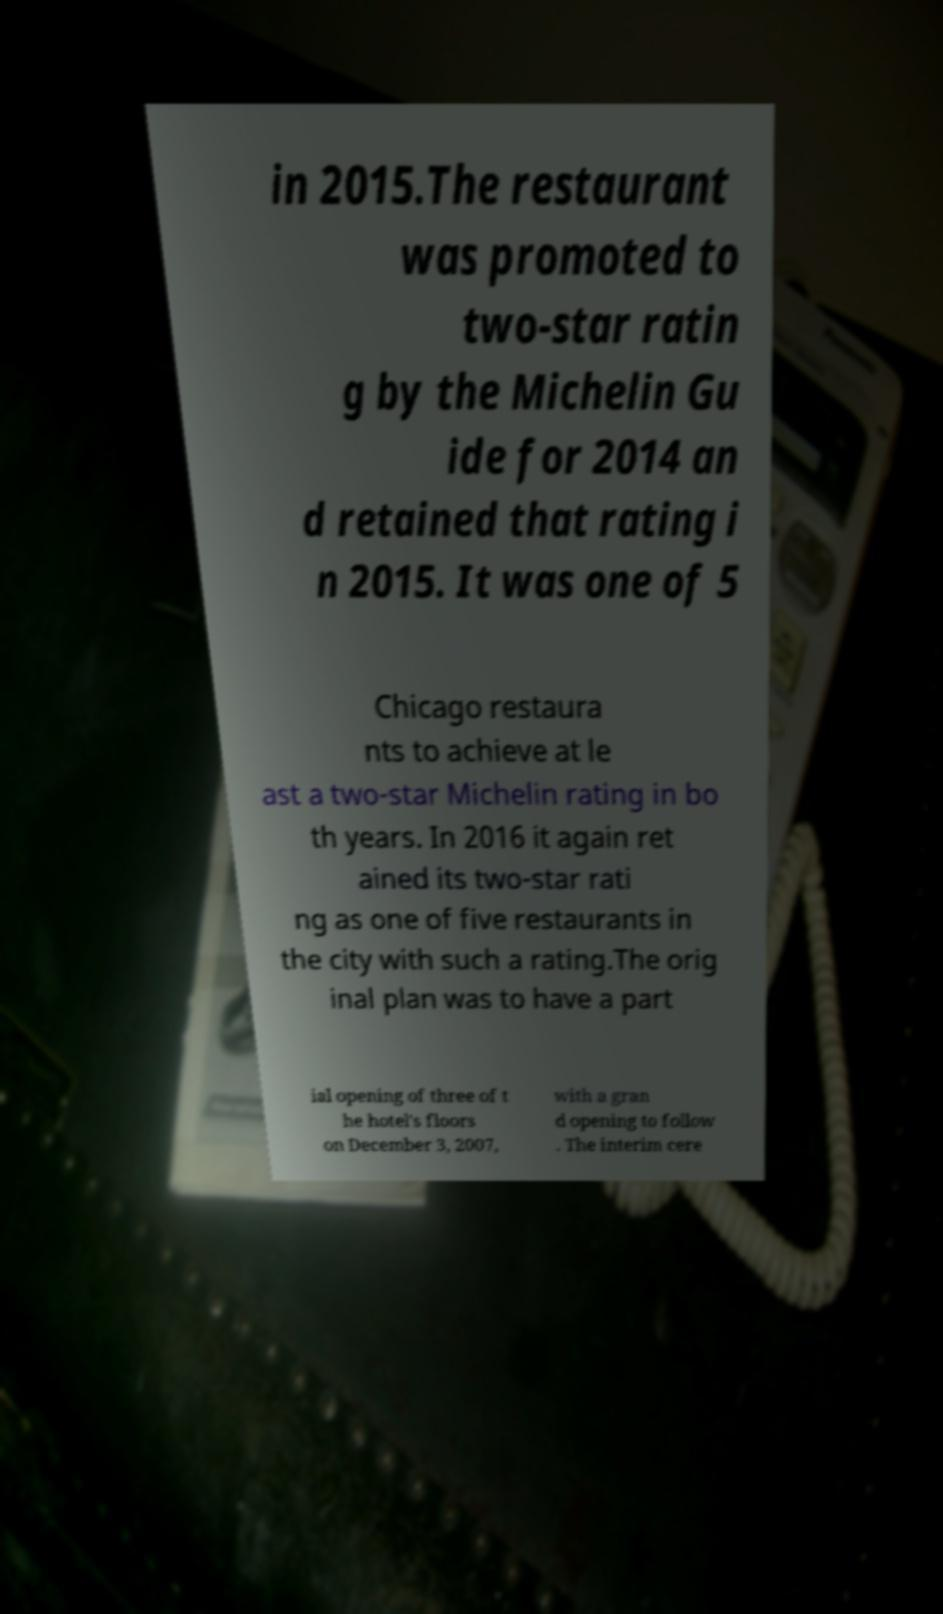There's text embedded in this image that I need extracted. Can you transcribe it verbatim? in 2015.The restaurant was promoted to two-star ratin g by the Michelin Gu ide for 2014 an d retained that rating i n 2015. It was one of 5 Chicago restaura nts to achieve at le ast a two-star Michelin rating in bo th years. In 2016 it again ret ained its two-star rati ng as one of five restaurants in the city with such a rating.The orig inal plan was to have a part ial opening of three of t he hotel's floors on December 3, 2007, with a gran d opening to follow . The interim cere 